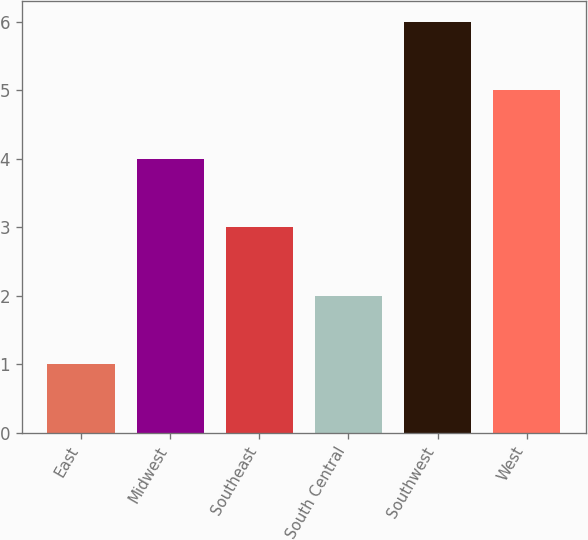<chart> <loc_0><loc_0><loc_500><loc_500><bar_chart><fcel>East<fcel>Midwest<fcel>Southeast<fcel>South Central<fcel>Southwest<fcel>West<nl><fcel>1<fcel>4<fcel>3<fcel>2<fcel>6<fcel>5<nl></chart> 